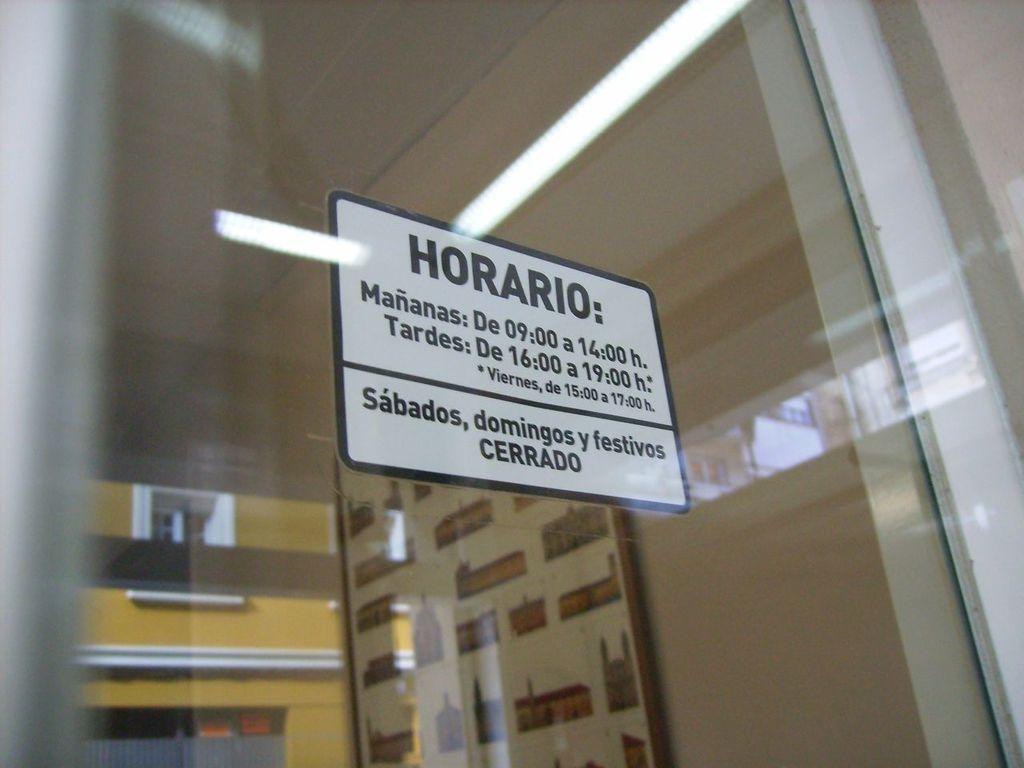What is on the glass in the image? There is a board on the glass. What can be seen through the glass in the image? There is a frame on the wall visible through the glass. What types of reflections are present on the glass? The glass has reflections of a building, a window, and lights. What type of juice can be seen in the pail in the image? There is no pail or juice present in the image. How does the vacation affect the board on the glass? The image does not mention a vacation, and therefore its effect on the board on the glass cannot be determined. 